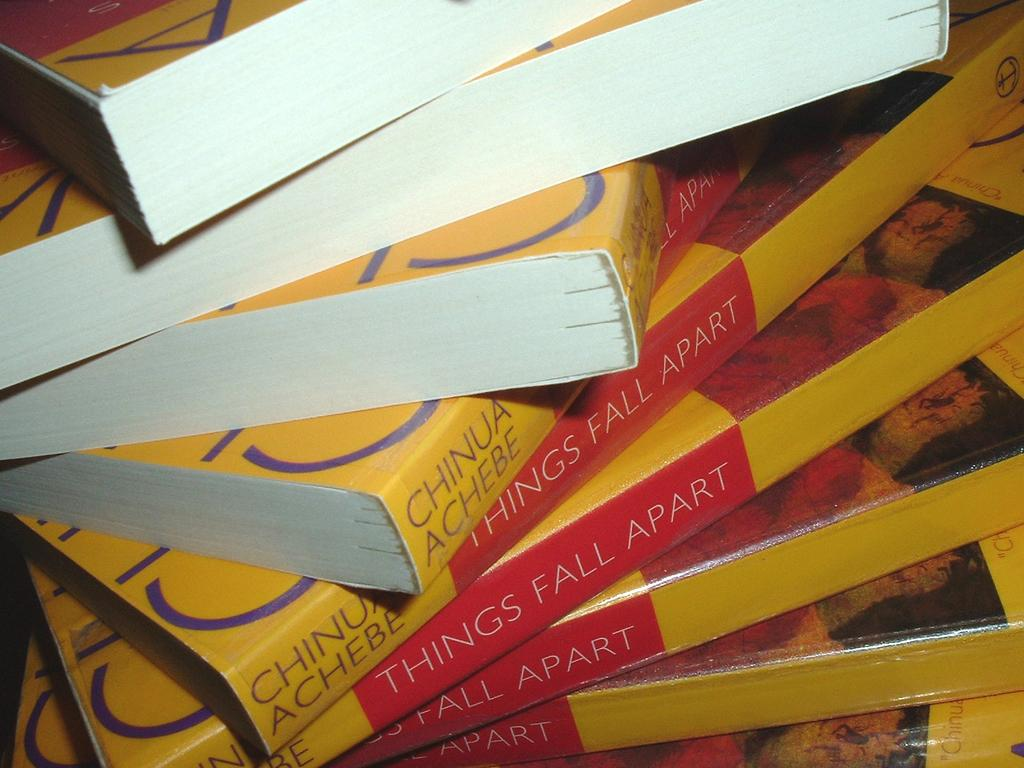<image>
Provide a brief description of the given image. A stack of Things Fall Apart by Chinua Achebe sits on a table. 